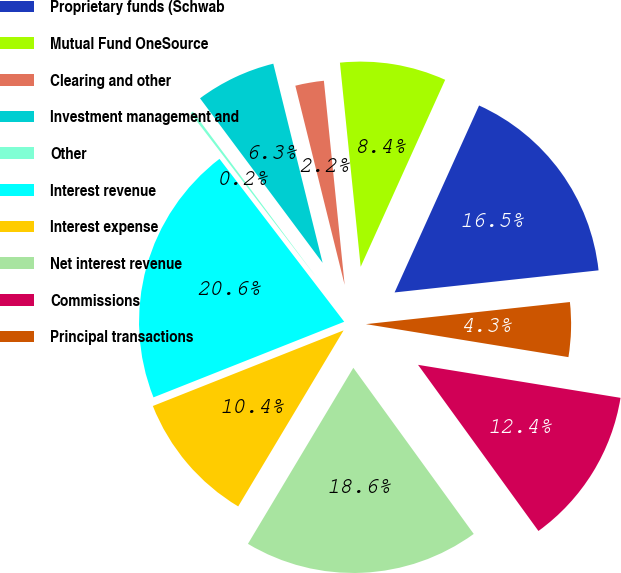Convert chart. <chart><loc_0><loc_0><loc_500><loc_500><pie_chart><fcel>Proprietary funds (Schwab<fcel>Mutual Fund OneSource <fcel>Clearing and other<fcel>Investment management and<fcel>Other<fcel>Interest revenue<fcel>Interest expense<fcel>Net interest revenue<fcel>Commissions<fcel>Principal transactions<nl><fcel>16.53%<fcel>8.37%<fcel>2.25%<fcel>6.33%<fcel>0.21%<fcel>20.61%<fcel>10.41%<fcel>18.57%<fcel>12.45%<fcel>4.29%<nl></chart> 